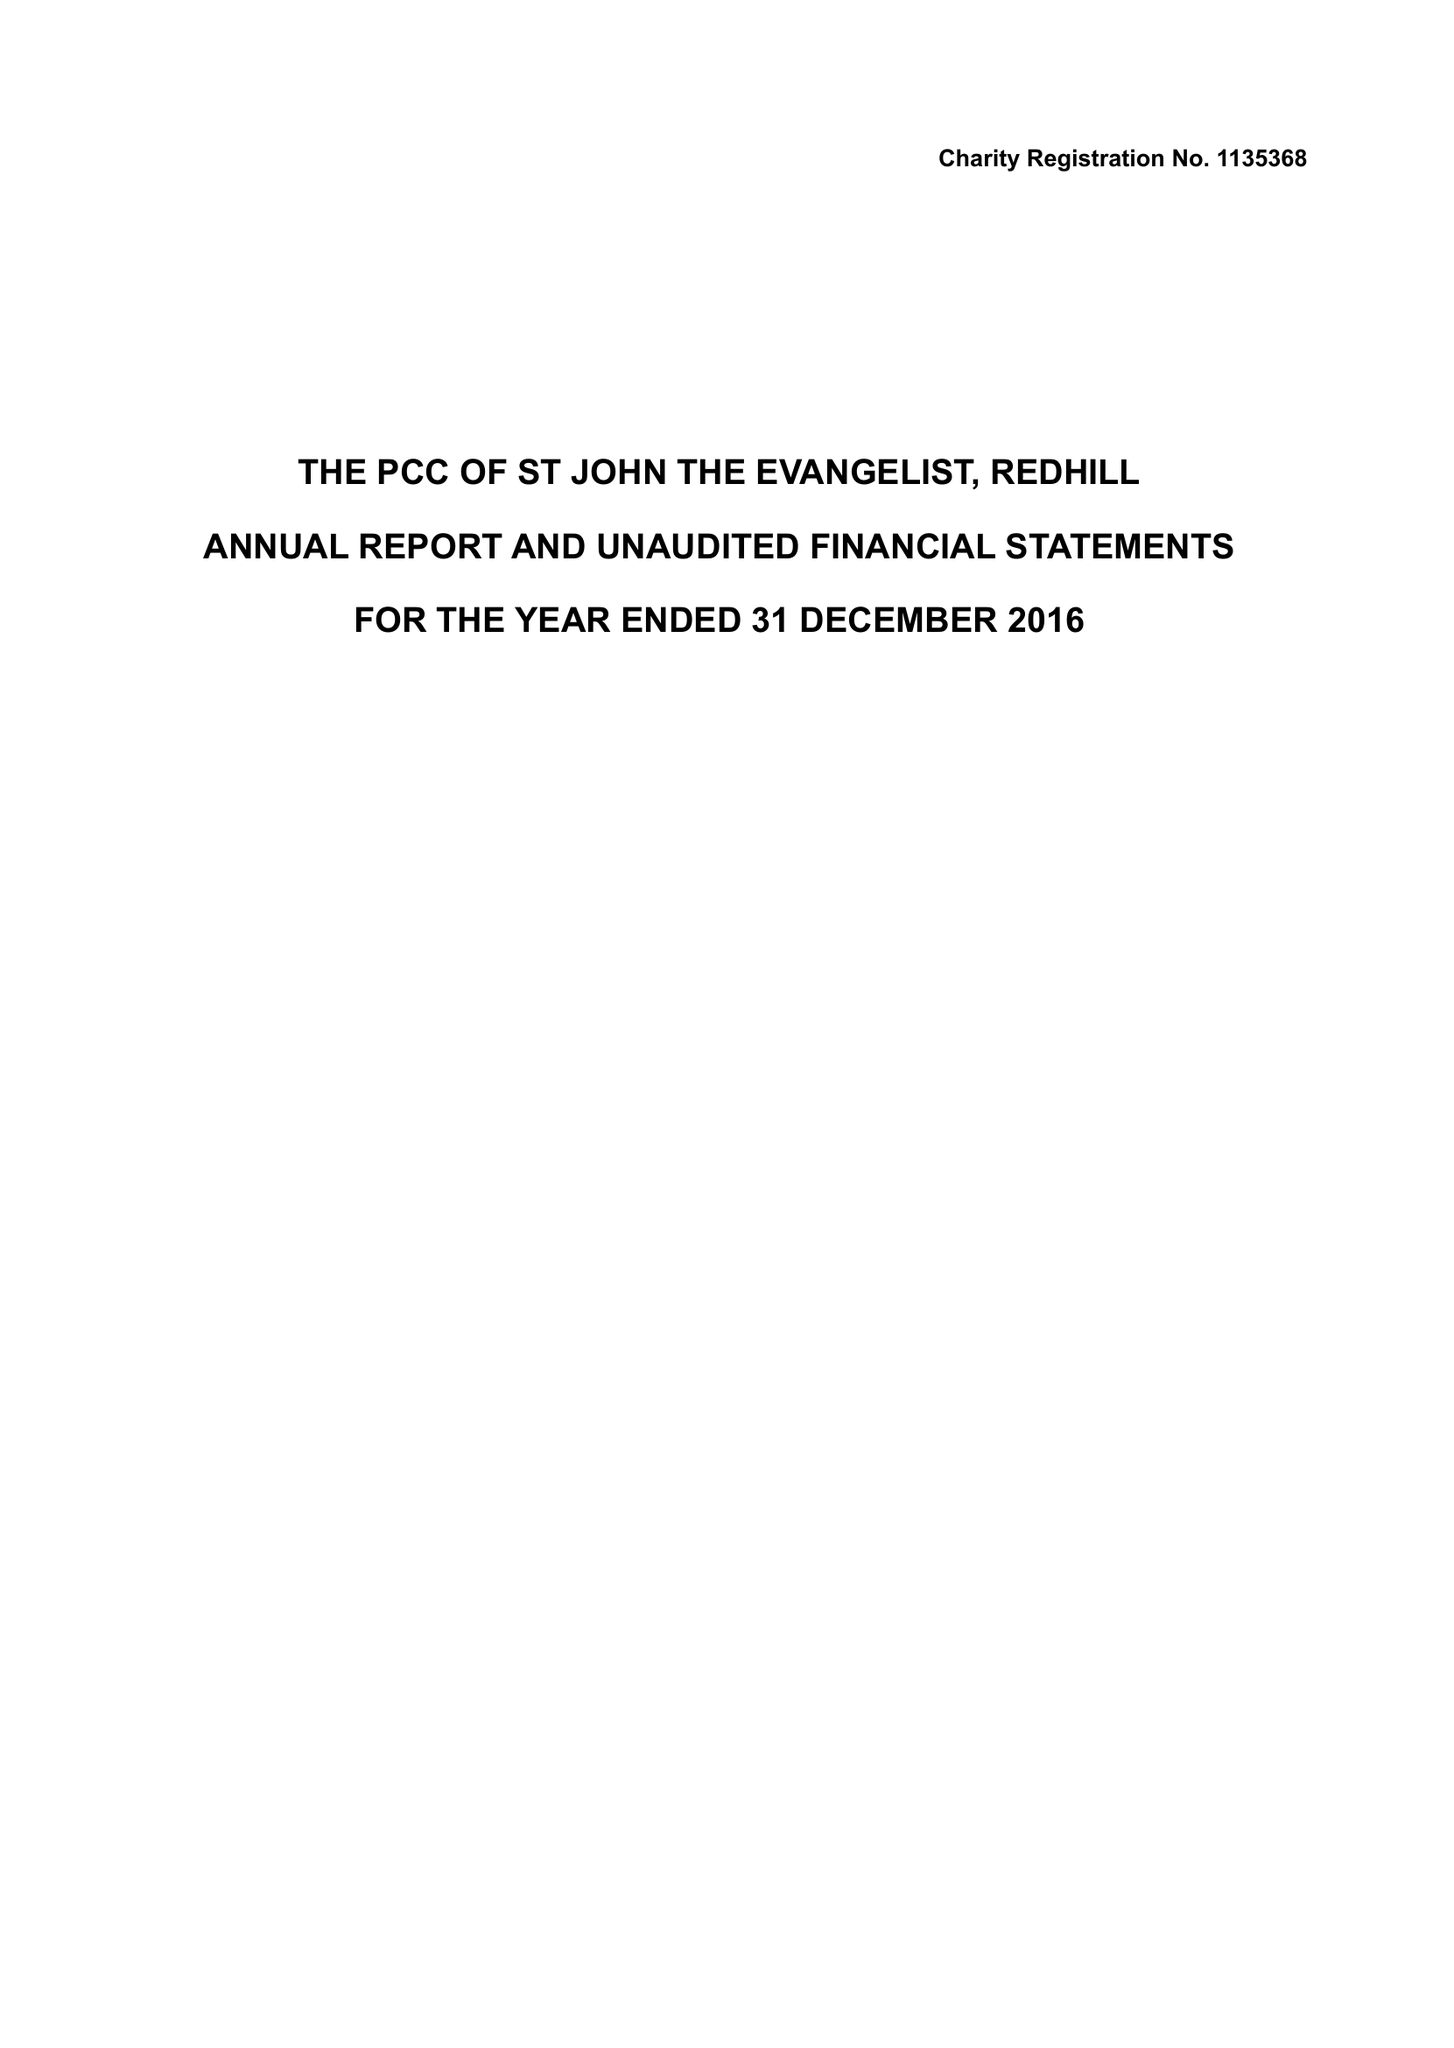What is the value for the spending_annually_in_british_pounds?
Answer the question using a single word or phrase. 162697.00 